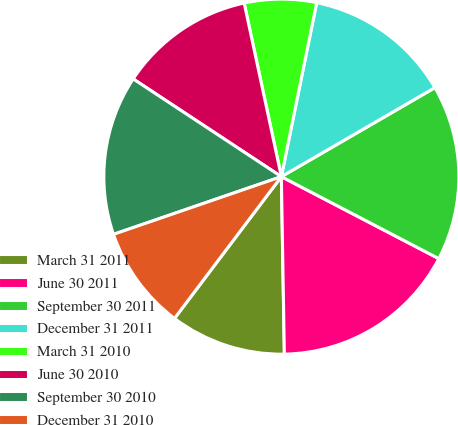Convert chart. <chart><loc_0><loc_0><loc_500><loc_500><pie_chart><fcel>March 31 2011<fcel>June 30 2011<fcel>September 30 2011<fcel>December 31 2011<fcel>March 31 2010<fcel>June 30 2010<fcel>September 30 2010<fcel>December 31 2010<nl><fcel>10.55%<fcel>17.09%<fcel>16.0%<fcel>13.45%<fcel>6.55%<fcel>12.36%<fcel>14.55%<fcel>9.45%<nl></chart> 